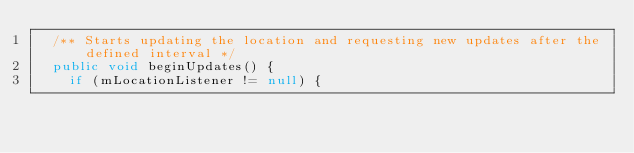Convert code to text. <code><loc_0><loc_0><loc_500><loc_500><_Java_>	/** Starts updating the location and requesting new updates after the defined interval */
	public void beginUpdates() {
		if (mLocationListener != null) {</code> 